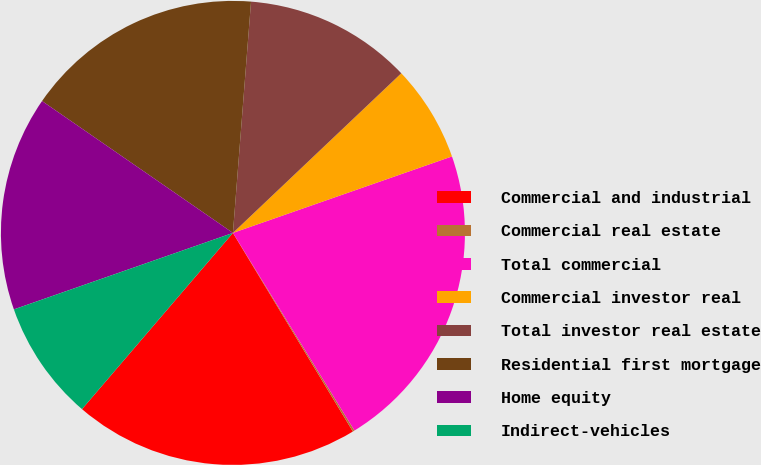Convert chart to OTSL. <chart><loc_0><loc_0><loc_500><loc_500><pie_chart><fcel>Commercial and industrial<fcel>Commercial real estate<fcel>Total commercial<fcel>Commercial investor real<fcel>Total investor real estate<fcel>Residential first mortgage<fcel>Home equity<fcel>Indirect-vehicles<nl><fcel>19.92%<fcel>0.13%<fcel>21.57%<fcel>6.73%<fcel>11.68%<fcel>16.62%<fcel>14.97%<fcel>8.38%<nl></chart> 